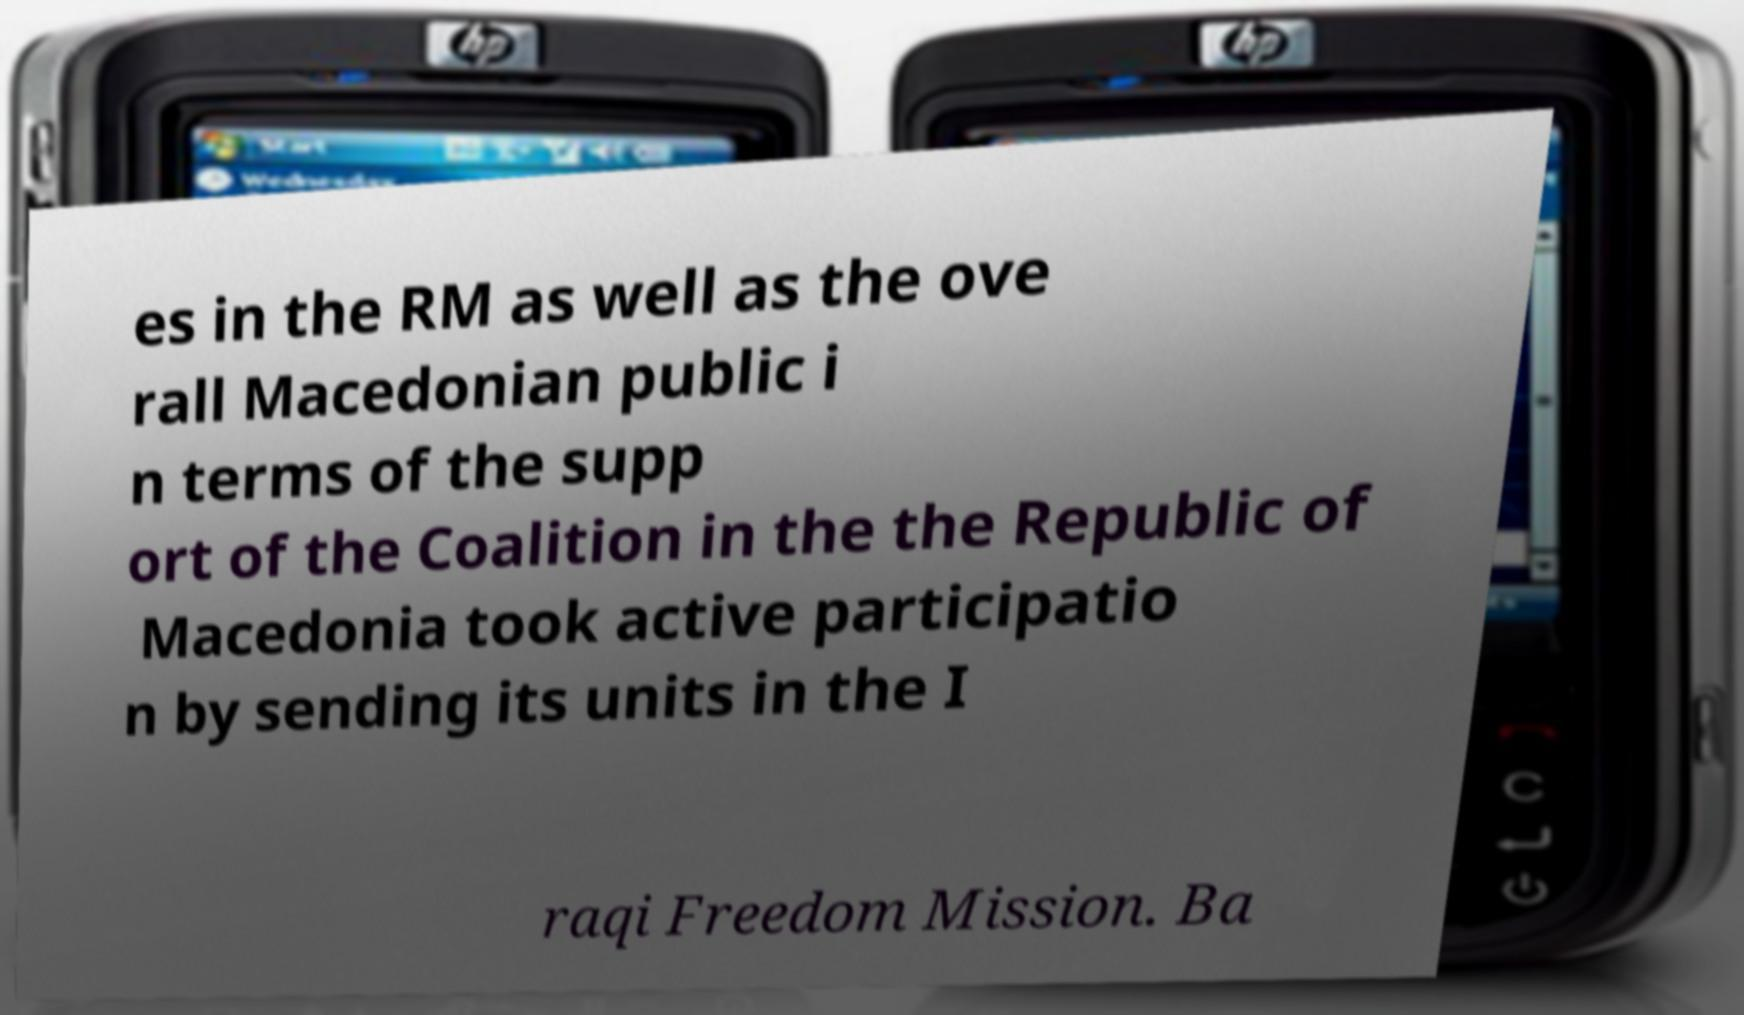There's text embedded in this image that I need extracted. Can you transcribe it verbatim? es in the RM as well as the ove rall Macedonian public i n terms of the supp ort of the Coalition in the the Republic of Macedonia took active participatio n by sending its units in the I raqi Freedom Mission. Ba 